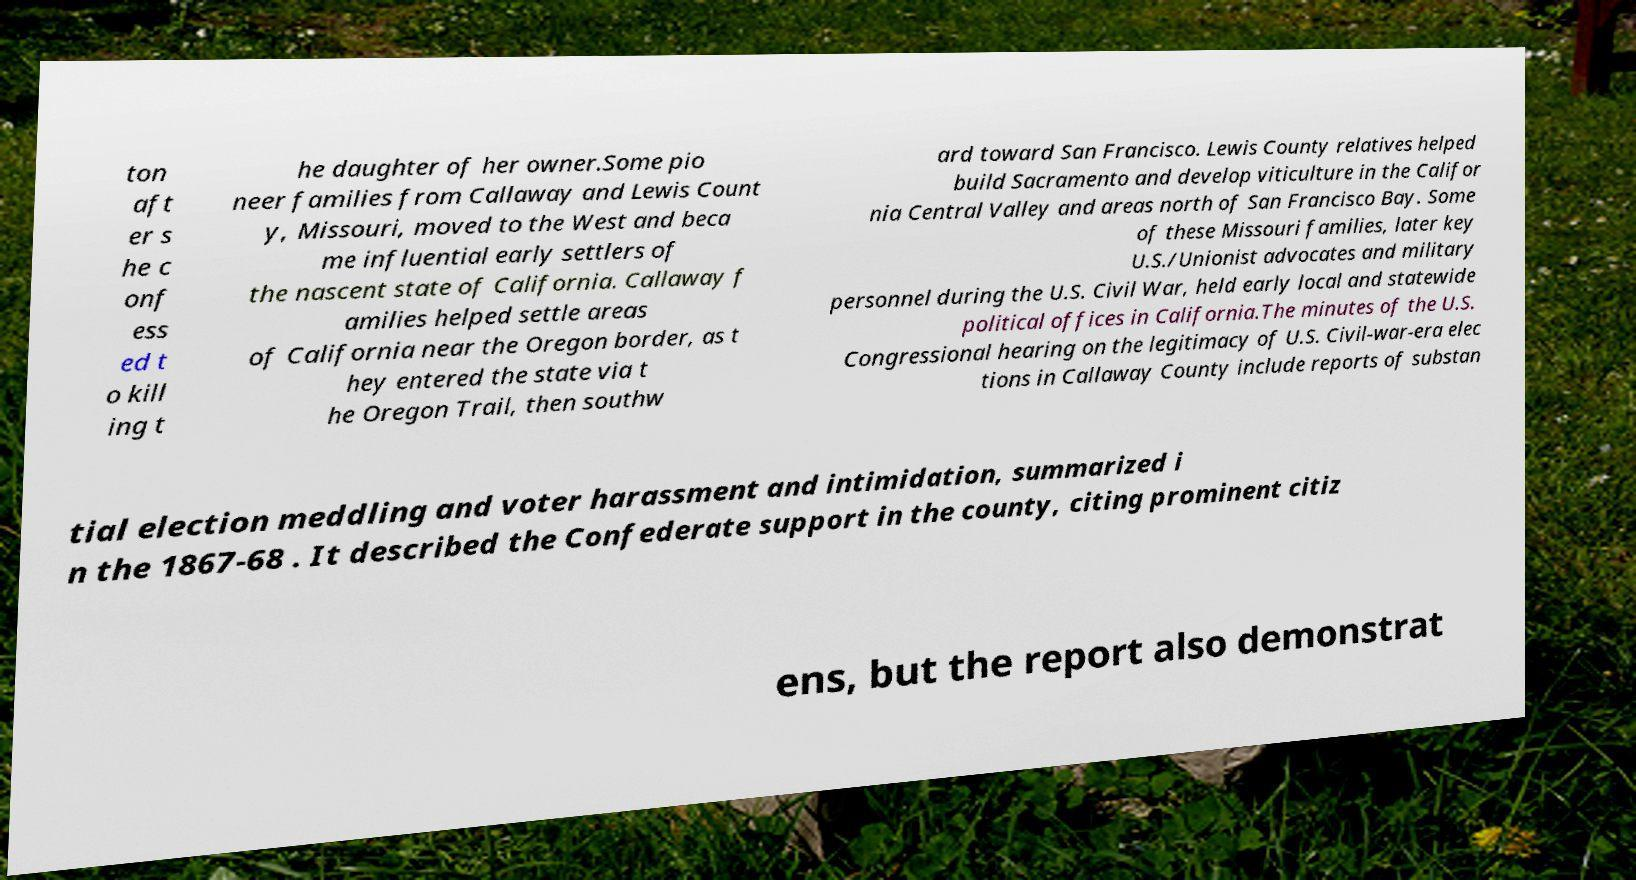For documentation purposes, I need the text within this image transcribed. Could you provide that? ton aft er s he c onf ess ed t o kill ing t he daughter of her owner.Some pio neer families from Callaway and Lewis Count y, Missouri, moved to the West and beca me influential early settlers of the nascent state of California. Callaway f amilies helped settle areas of California near the Oregon border, as t hey entered the state via t he Oregon Trail, then southw ard toward San Francisco. Lewis County relatives helped build Sacramento and develop viticulture in the Califor nia Central Valley and areas north of San Francisco Bay. Some of these Missouri families, later key U.S./Unionist advocates and military personnel during the U.S. Civil War, held early local and statewide political offices in California.The minutes of the U.S. Congressional hearing on the legitimacy of U.S. Civil-war-era elec tions in Callaway County include reports of substan tial election meddling and voter harassment and intimidation, summarized i n the 1867-68 . It described the Confederate support in the county, citing prominent citiz ens, but the report also demonstrat 